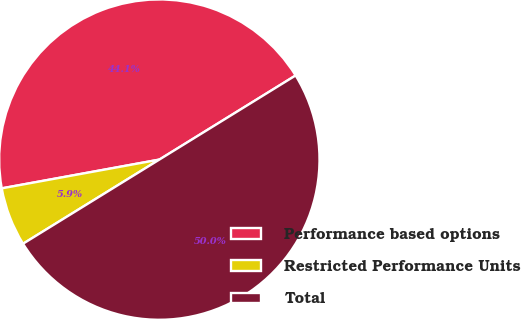Convert chart. <chart><loc_0><loc_0><loc_500><loc_500><pie_chart><fcel>Performance based options<fcel>Restricted Performance Units<fcel>Total<nl><fcel>44.07%<fcel>5.93%<fcel>50.0%<nl></chart> 